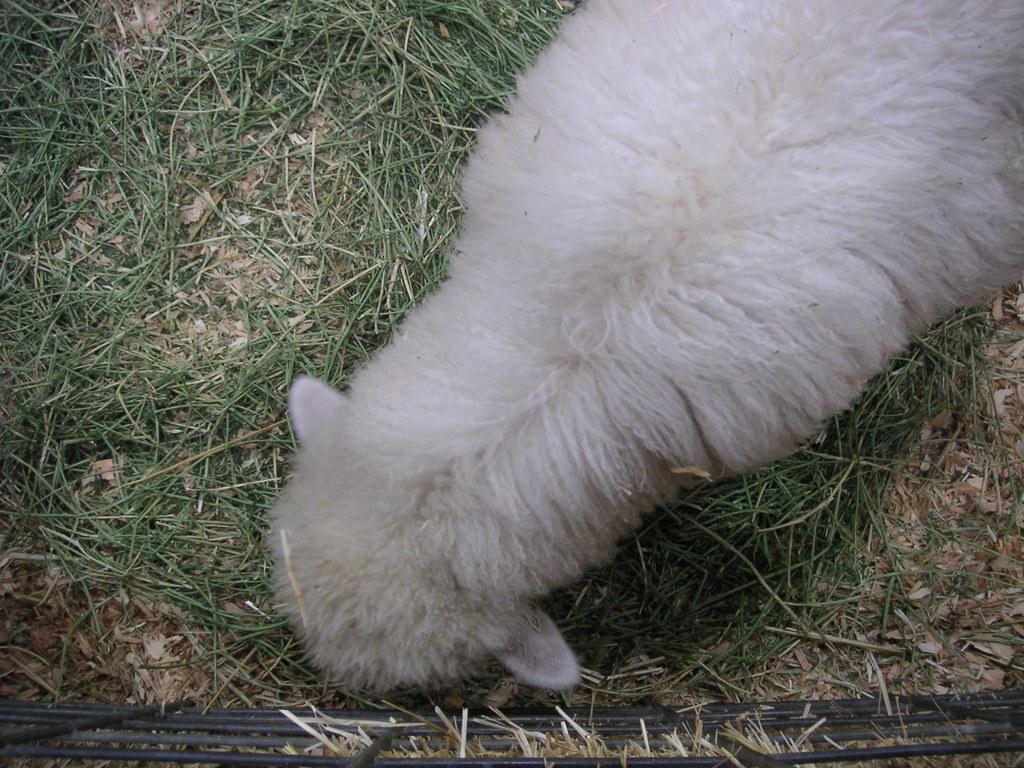How would you summarize this image in a sentence or two? In this picture there is a white lamb standing and eating the grass. At the bottom there is grass. In the foreground there is a railing. 